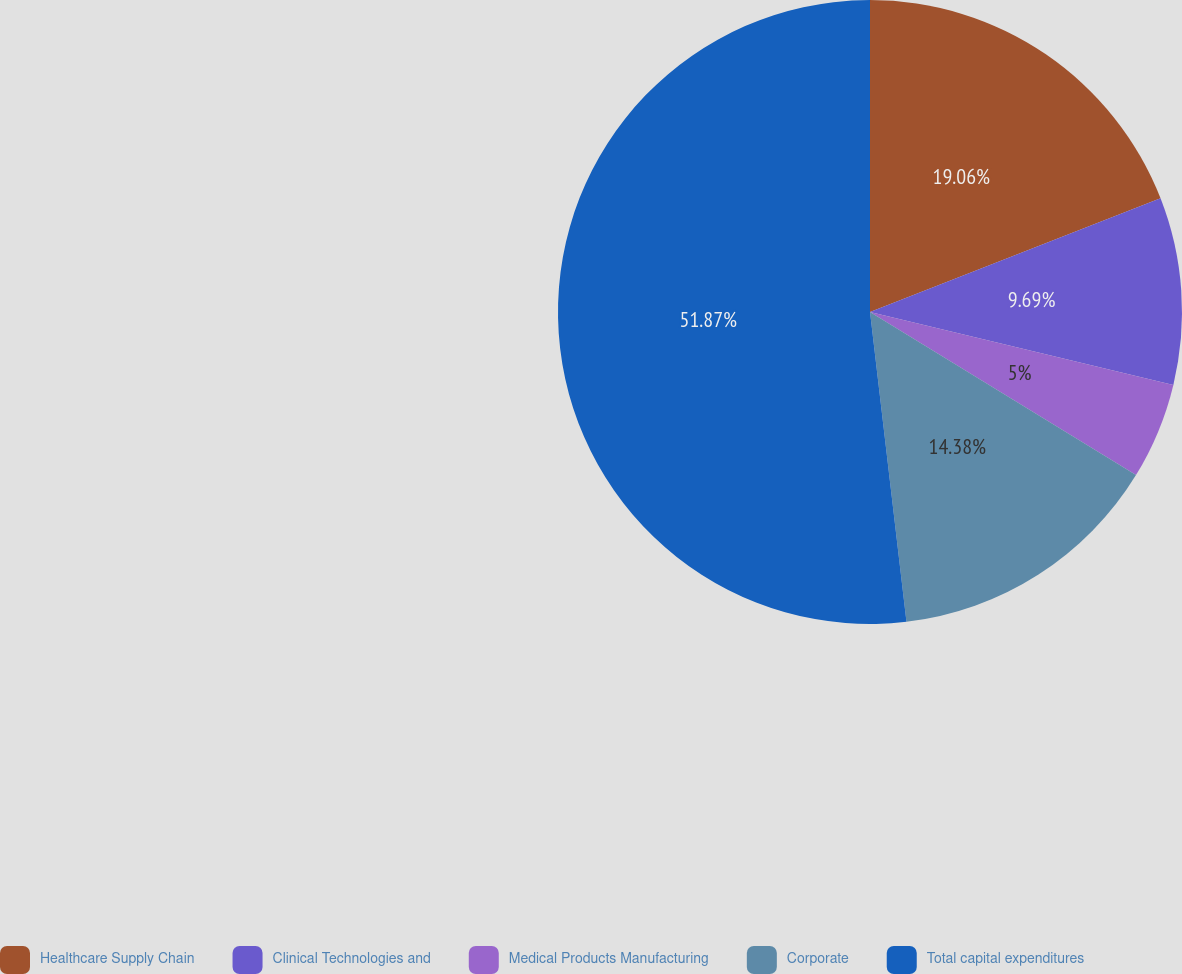Convert chart. <chart><loc_0><loc_0><loc_500><loc_500><pie_chart><fcel>Healthcare Supply Chain<fcel>Clinical Technologies and<fcel>Medical Products Manufacturing<fcel>Corporate<fcel>Total capital expenditures<nl><fcel>19.06%<fcel>9.69%<fcel>5.0%<fcel>14.38%<fcel>51.86%<nl></chart> 